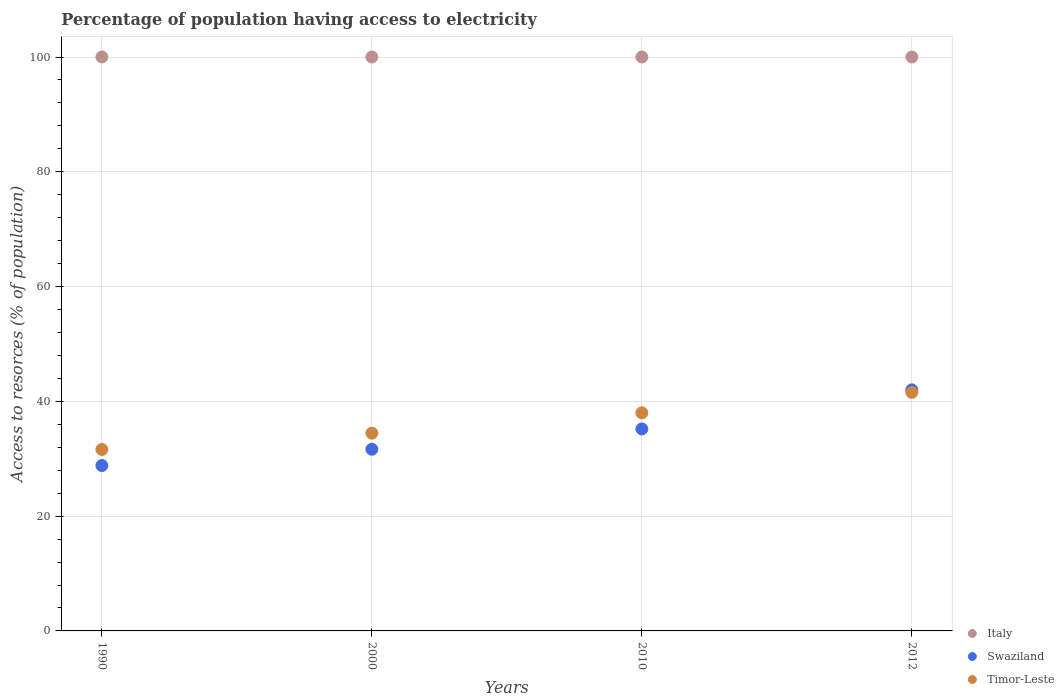What is the percentage of population having access to electricity in Italy in 2000?
Your answer should be compact. 100. Across all years, what is the maximum percentage of population having access to electricity in Swaziland?
Offer a very short reply. 42. Across all years, what is the minimum percentage of population having access to electricity in Timor-Leste?
Provide a succinct answer. 31.62. In which year was the percentage of population having access to electricity in Italy maximum?
Keep it short and to the point. 1990. In which year was the percentage of population having access to electricity in Timor-Leste minimum?
Keep it short and to the point. 1990. What is the total percentage of population having access to electricity in Timor-Leste in the graph?
Provide a short and direct response. 145.63. What is the difference between the percentage of population having access to electricity in Timor-Leste in 2000 and that in 2012?
Provide a succinct answer. -7.11. What is the difference between the percentage of population having access to electricity in Timor-Leste in 1990 and the percentage of population having access to electricity in Swaziland in 2012?
Keep it short and to the point. -10.38. What is the average percentage of population having access to electricity in Timor-Leste per year?
Ensure brevity in your answer.  36.41. In the year 2010, what is the difference between the percentage of population having access to electricity in Swaziland and percentage of population having access to electricity in Italy?
Provide a succinct answer. -64.8. In how many years, is the percentage of population having access to electricity in Timor-Leste greater than 56 %?
Keep it short and to the point. 0. What is the ratio of the percentage of population having access to electricity in Swaziland in 2010 to that in 2012?
Your response must be concise. 0.84. Is the difference between the percentage of population having access to electricity in Swaziland in 1990 and 2012 greater than the difference between the percentage of population having access to electricity in Italy in 1990 and 2012?
Give a very brief answer. No. What is the difference between the highest and the second highest percentage of population having access to electricity in Italy?
Your answer should be very brief. 0. What is the difference between the highest and the lowest percentage of population having access to electricity in Timor-Leste?
Provide a short and direct response. 9.95. Is the sum of the percentage of population having access to electricity in Italy in 2000 and 2010 greater than the maximum percentage of population having access to electricity in Swaziland across all years?
Your answer should be compact. Yes. Is the percentage of population having access to electricity in Timor-Leste strictly less than the percentage of population having access to electricity in Swaziland over the years?
Provide a short and direct response. No. How many years are there in the graph?
Ensure brevity in your answer.  4. Where does the legend appear in the graph?
Offer a very short reply. Bottom right. How many legend labels are there?
Provide a succinct answer. 3. How are the legend labels stacked?
Ensure brevity in your answer.  Vertical. What is the title of the graph?
Keep it short and to the point. Percentage of population having access to electricity. Does "Small states" appear as one of the legend labels in the graph?
Your response must be concise. No. What is the label or title of the X-axis?
Offer a very short reply. Years. What is the label or title of the Y-axis?
Give a very brief answer. Access to resorces (% of population). What is the Access to resorces (% of population) of Swaziland in 1990?
Your answer should be compact. 28.82. What is the Access to resorces (% of population) in Timor-Leste in 1990?
Provide a short and direct response. 31.62. What is the Access to resorces (% of population) of Swaziland in 2000?
Your answer should be very brief. 31.66. What is the Access to resorces (% of population) of Timor-Leste in 2000?
Provide a short and direct response. 34.46. What is the Access to resorces (% of population) in Swaziland in 2010?
Your answer should be very brief. 35.2. What is the Access to resorces (% of population) of Timor-Leste in 2010?
Keep it short and to the point. 38. What is the Access to resorces (% of population) of Timor-Leste in 2012?
Provide a short and direct response. 41.56. Across all years, what is the maximum Access to resorces (% of population) of Timor-Leste?
Give a very brief answer. 41.56. Across all years, what is the minimum Access to resorces (% of population) in Swaziland?
Ensure brevity in your answer.  28.82. Across all years, what is the minimum Access to resorces (% of population) in Timor-Leste?
Keep it short and to the point. 31.62. What is the total Access to resorces (% of population) of Italy in the graph?
Ensure brevity in your answer.  400. What is the total Access to resorces (% of population) of Swaziland in the graph?
Ensure brevity in your answer.  137.67. What is the total Access to resorces (% of population) in Timor-Leste in the graph?
Offer a very short reply. 145.63. What is the difference between the Access to resorces (% of population) in Swaziland in 1990 and that in 2000?
Make the answer very short. -2.84. What is the difference between the Access to resorces (% of population) in Timor-Leste in 1990 and that in 2000?
Provide a short and direct response. -2.84. What is the difference between the Access to resorces (% of population) of Swaziland in 1990 and that in 2010?
Make the answer very short. -6.38. What is the difference between the Access to resorces (% of population) in Timor-Leste in 1990 and that in 2010?
Your response must be concise. -6.38. What is the difference between the Access to resorces (% of population) in Swaziland in 1990 and that in 2012?
Your response must be concise. -13.18. What is the difference between the Access to resorces (% of population) of Timor-Leste in 1990 and that in 2012?
Offer a terse response. -9.95. What is the difference between the Access to resorces (% of population) in Swaziland in 2000 and that in 2010?
Give a very brief answer. -3.54. What is the difference between the Access to resorces (% of population) of Timor-Leste in 2000 and that in 2010?
Give a very brief answer. -3.54. What is the difference between the Access to resorces (% of population) in Italy in 2000 and that in 2012?
Your response must be concise. 0. What is the difference between the Access to resorces (% of population) of Swaziland in 2000 and that in 2012?
Your answer should be compact. -10.34. What is the difference between the Access to resorces (% of population) of Timor-Leste in 2000 and that in 2012?
Offer a very short reply. -7.11. What is the difference between the Access to resorces (% of population) in Italy in 2010 and that in 2012?
Ensure brevity in your answer.  0. What is the difference between the Access to resorces (% of population) of Swaziland in 2010 and that in 2012?
Give a very brief answer. -6.8. What is the difference between the Access to resorces (% of population) in Timor-Leste in 2010 and that in 2012?
Give a very brief answer. -3.56. What is the difference between the Access to resorces (% of population) of Italy in 1990 and the Access to resorces (% of population) of Swaziland in 2000?
Offer a terse response. 68.34. What is the difference between the Access to resorces (% of population) in Italy in 1990 and the Access to resorces (% of population) in Timor-Leste in 2000?
Your response must be concise. 65.54. What is the difference between the Access to resorces (% of population) of Swaziland in 1990 and the Access to resorces (% of population) of Timor-Leste in 2000?
Offer a terse response. -5.64. What is the difference between the Access to resorces (% of population) of Italy in 1990 and the Access to resorces (% of population) of Swaziland in 2010?
Ensure brevity in your answer.  64.8. What is the difference between the Access to resorces (% of population) in Italy in 1990 and the Access to resorces (% of population) in Timor-Leste in 2010?
Offer a very short reply. 62. What is the difference between the Access to resorces (% of population) in Swaziland in 1990 and the Access to resorces (% of population) in Timor-Leste in 2010?
Provide a succinct answer. -9.18. What is the difference between the Access to resorces (% of population) of Italy in 1990 and the Access to resorces (% of population) of Timor-Leste in 2012?
Provide a succinct answer. 58.44. What is the difference between the Access to resorces (% of population) of Swaziland in 1990 and the Access to resorces (% of population) of Timor-Leste in 2012?
Provide a short and direct response. -12.75. What is the difference between the Access to resorces (% of population) in Italy in 2000 and the Access to resorces (% of population) in Swaziland in 2010?
Give a very brief answer. 64.8. What is the difference between the Access to resorces (% of population) in Italy in 2000 and the Access to resorces (% of population) in Timor-Leste in 2010?
Your answer should be compact. 62. What is the difference between the Access to resorces (% of population) in Swaziland in 2000 and the Access to resorces (% of population) in Timor-Leste in 2010?
Offer a terse response. -6.34. What is the difference between the Access to resorces (% of population) in Italy in 2000 and the Access to resorces (% of population) in Timor-Leste in 2012?
Your response must be concise. 58.44. What is the difference between the Access to resorces (% of population) in Swaziland in 2000 and the Access to resorces (% of population) in Timor-Leste in 2012?
Make the answer very short. -9.91. What is the difference between the Access to resorces (% of population) in Italy in 2010 and the Access to resorces (% of population) in Timor-Leste in 2012?
Your answer should be compact. 58.44. What is the difference between the Access to resorces (% of population) in Swaziland in 2010 and the Access to resorces (% of population) in Timor-Leste in 2012?
Ensure brevity in your answer.  -6.36. What is the average Access to resorces (% of population) of Italy per year?
Provide a short and direct response. 100. What is the average Access to resorces (% of population) of Swaziland per year?
Ensure brevity in your answer.  34.42. What is the average Access to resorces (% of population) of Timor-Leste per year?
Your response must be concise. 36.41. In the year 1990, what is the difference between the Access to resorces (% of population) in Italy and Access to resorces (% of population) in Swaziland?
Keep it short and to the point. 71.18. In the year 1990, what is the difference between the Access to resorces (% of population) of Italy and Access to resorces (% of population) of Timor-Leste?
Your response must be concise. 68.38. In the year 2000, what is the difference between the Access to resorces (% of population) of Italy and Access to resorces (% of population) of Swaziland?
Ensure brevity in your answer.  68.34. In the year 2000, what is the difference between the Access to resorces (% of population) in Italy and Access to resorces (% of population) in Timor-Leste?
Offer a terse response. 65.54. In the year 2000, what is the difference between the Access to resorces (% of population) in Swaziland and Access to resorces (% of population) in Timor-Leste?
Provide a succinct answer. -2.8. In the year 2010, what is the difference between the Access to resorces (% of population) of Italy and Access to resorces (% of population) of Swaziland?
Your answer should be compact. 64.8. In the year 2012, what is the difference between the Access to resorces (% of population) in Italy and Access to resorces (% of population) in Swaziland?
Your answer should be compact. 58. In the year 2012, what is the difference between the Access to resorces (% of population) in Italy and Access to resorces (% of population) in Timor-Leste?
Provide a short and direct response. 58.44. In the year 2012, what is the difference between the Access to resorces (% of population) of Swaziland and Access to resorces (% of population) of Timor-Leste?
Ensure brevity in your answer.  0.44. What is the ratio of the Access to resorces (% of population) of Italy in 1990 to that in 2000?
Give a very brief answer. 1. What is the ratio of the Access to resorces (% of population) in Swaziland in 1990 to that in 2000?
Offer a terse response. 0.91. What is the ratio of the Access to resorces (% of population) in Timor-Leste in 1990 to that in 2000?
Your response must be concise. 0.92. What is the ratio of the Access to resorces (% of population) in Italy in 1990 to that in 2010?
Offer a very short reply. 1. What is the ratio of the Access to resorces (% of population) of Swaziland in 1990 to that in 2010?
Your response must be concise. 0.82. What is the ratio of the Access to resorces (% of population) in Timor-Leste in 1990 to that in 2010?
Offer a very short reply. 0.83. What is the ratio of the Access to resorces (% of population) in Swaziland in 1990 to that in 2012?
Ensure brevity in your answer.  0.69. What is the ratio of the Access to resorces (% of population) of Timor-Leste in 1990 to that in 2012?
Ensure brevity in your answer.  0.76. What is the ratio of the Access to resorces (% of population) of Italy in 2000 to that in 2010?
Offer a terse response. 1. What is the ratio of the Access to resorces (% of population) of Swaziland in 2000 to that in 2010?
Provide a short and direct response. 0.9. What is the ratio of the Access to resorces (% of population) in Timor-Leste in 2000 to that in 2010?
Make the answer very short. 0.91. What is the ratio of the Access to resorces (% of population) of Italy in 2000 to that in 2012?
Your answer should be very brief. 1. What is the ratio of the Access to resorces (% of population) in Swaziland in 2000 to that in 2012?
Give a very brief answer. 0.75. What is the ratio of the Access to resorces (% of population) in Timor-Leste in 2000 to that in 2012?
Provide a short and direct response. 0.83. What is the ratio of the Access to resorces (% of population) of Italy in 2010 to that in 2012?
Give a very brief answer. 1. What is the ratio of the Access to resorces (% of population) of Swaziland in 2010 to that in 2012?
Your answer should be very brief. 0.84. What is the ratio of the Access to resorces (% of population) of Timor-Leste in 2010 to that in 2012?
Provide a succinct answer. 0.91. What is the difference between the highest and the second highest Access to resorces (% of population) of Italy?
Make the answer very short. 0. What is the difference between the highest and the second highest Access to resorces (% of population) of Timor-Leste?
Your answer should be compact. 3.56. What is the difference between the highest and the lowest Access to resorces (% of population) of Swaziland?
Make the answer very short. 13.18. What is the difference between the highest and the lowest Access to resorces (% of population) in Timor-Leste?
Your response must be concise. 9.95. 